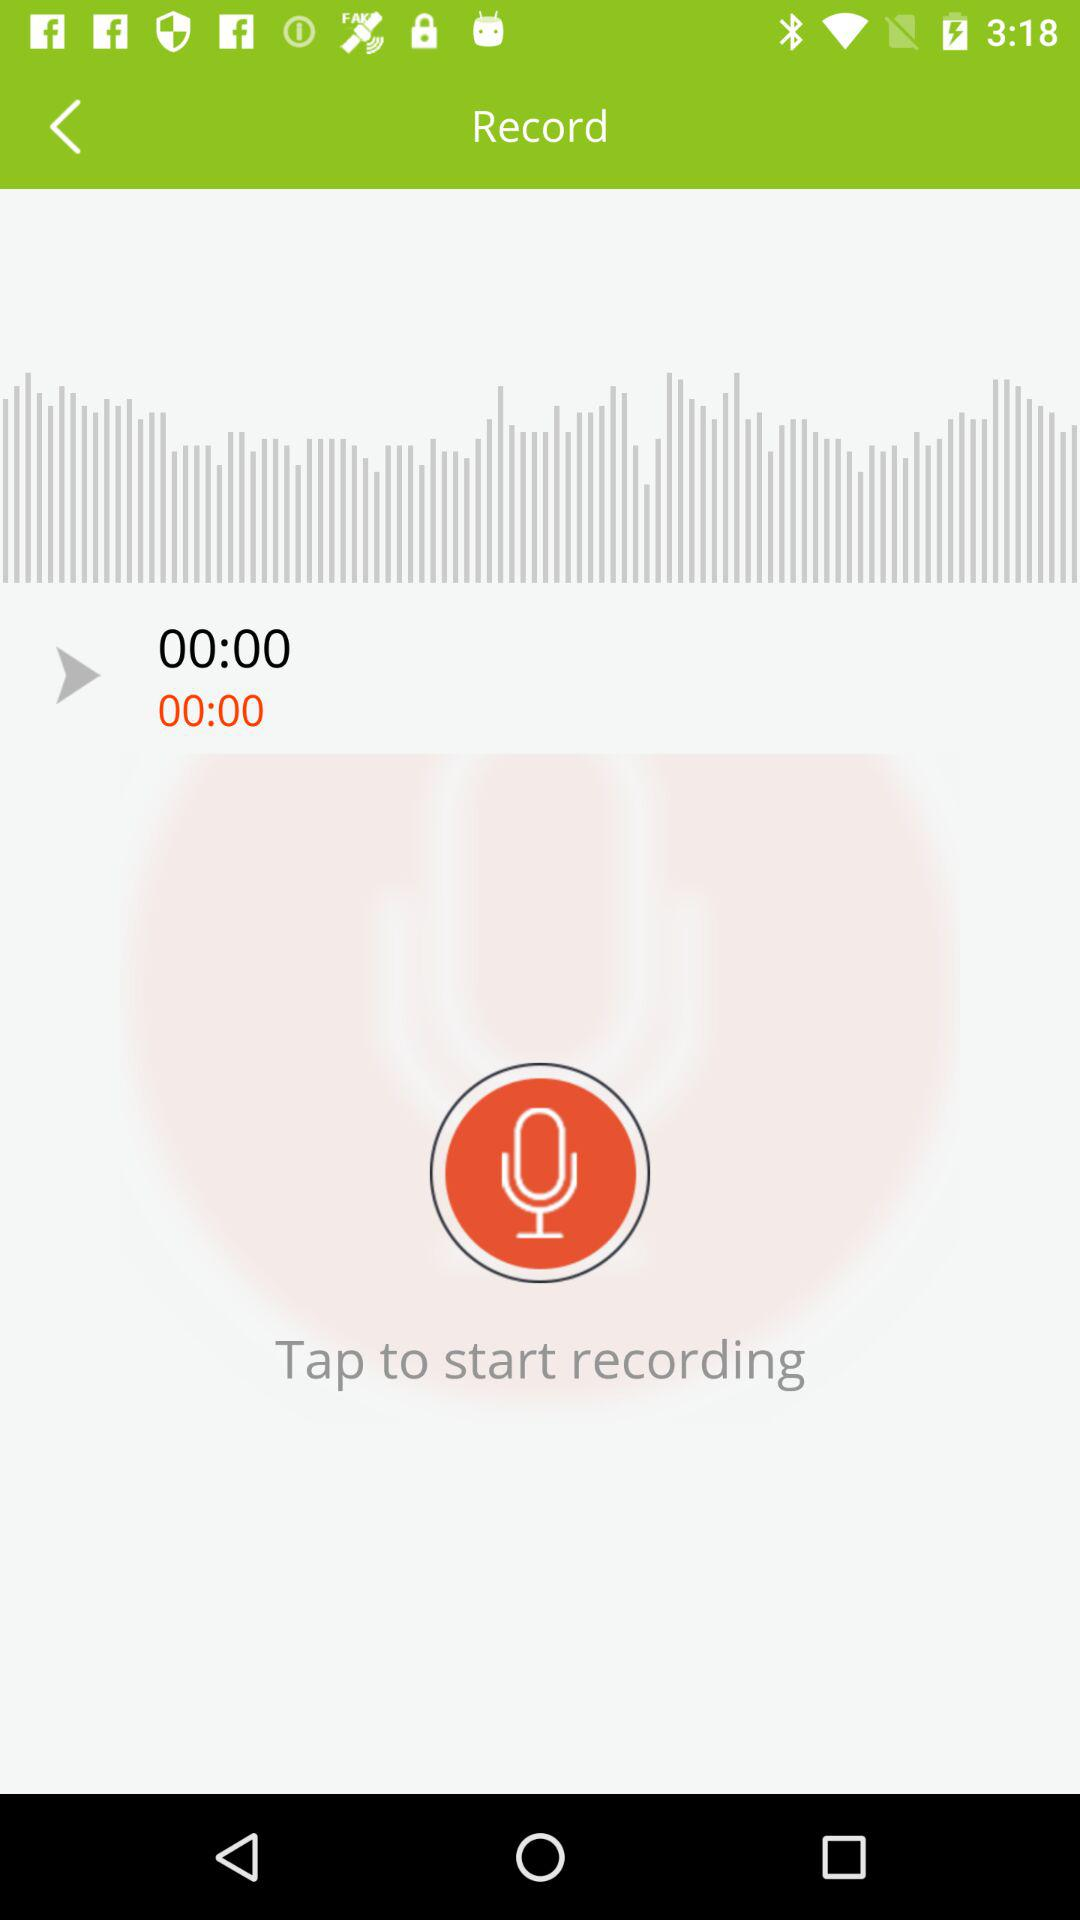What is the duration of record?
When the provided information is insufficient, respond with <no answer>. <no answer> 